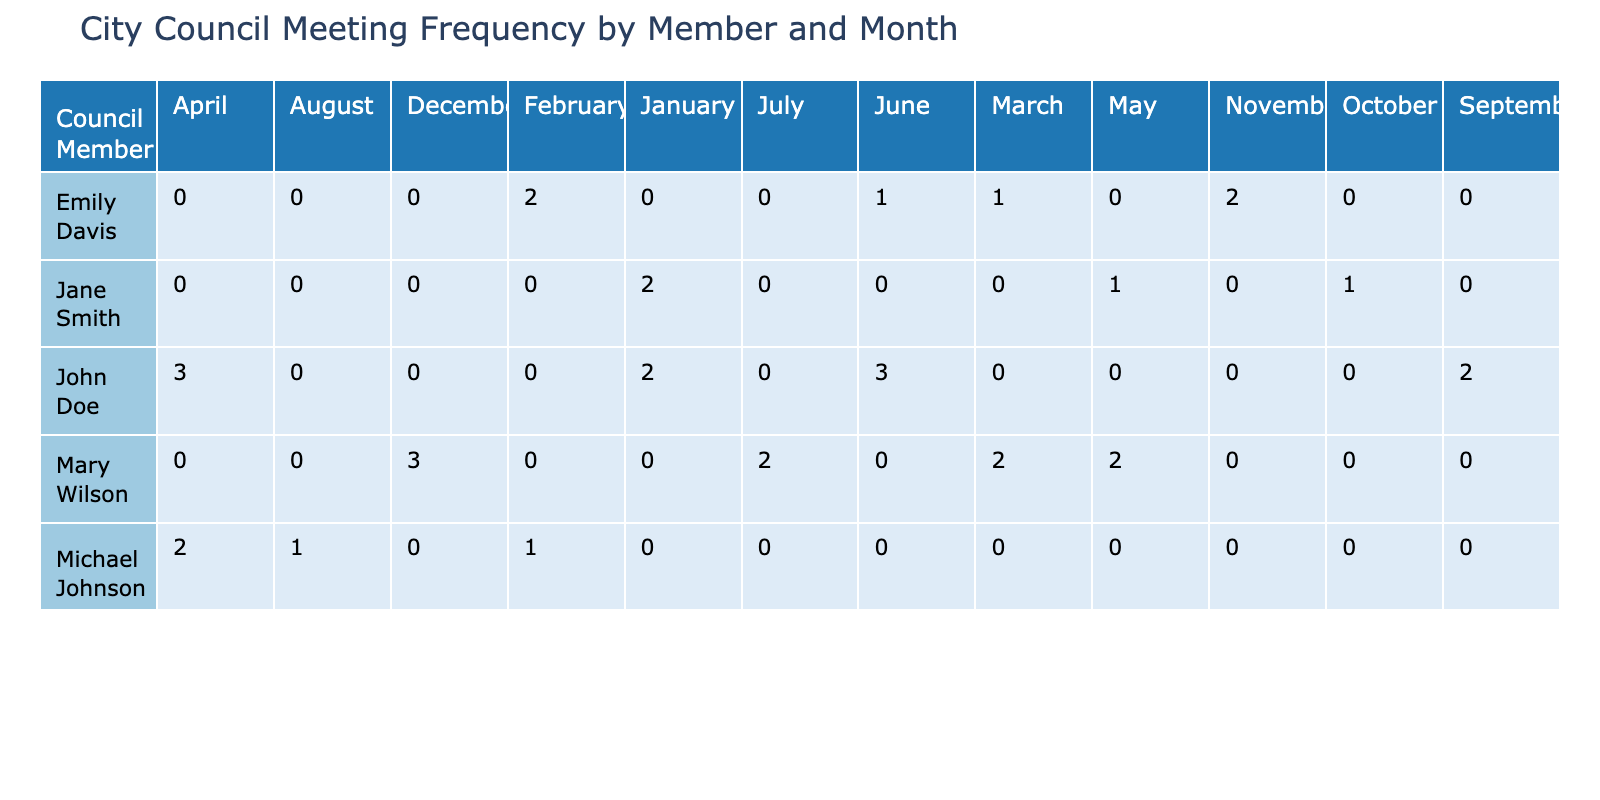What is the total number of meetings held by John Doe? To find the total number of meetings held by John Doe, I will look at the row for John Doe in the table and sum the values in the "Meeting_Count" column across all months. The values are 2 (January), 3 (April), 3 (June), and 2 (September), totaling 2 + 3 + 3 + 2 = 10.
Answer: 10 Which council member had the highest participation rate overall? I need to analyze the participation rates for each council member over the months. The maximum participation rates are: John Doe 100% (January, April, June, September), Jane Smith 100% (January, May), Emily Davis 100% (February), and Mary Wilson 100% (December). All these members had instances of 100%, thus it’s a tie among multiple members for the highest rate.
Answer: Tie among John Doe, Jane Smith, Emily Davis, and Mary Wilson How many meetings did Emily Davis attend in total? I will accumulate the "Meeting_Count" for Emily Davis. The values are 2 (February), 1 (March), 1 (June), and 2 (November), resulting in a total of 2 + 1 + 1 + 2 = 6 meetings attended.
Answer: 6 Is it true that Michael Johnson had a participation rate below 75% in any month? I look at Michael Johnson’s participation rates for each month: 100% (January), 50% (February), and 50% (August). Since he has two instances at 50%, which is below 75%, the answer is true.
Answer: Yes What is the average number of meetings attended by council members in March? In March, we have the following Meeting_Counts: Emily Davis 1 and Mary Wilson 2. To find the average, I sum these values (1 + 2 = 3) and then divide by the number of council members (2), giving an average of 3/2 = 1.5 meetings.
Answer: 1.5 Which month had the highest total number of meetings held? I will sum the meeting counts for each month: January (4), February (3), March (3), April (5), May (3), June (4), July (2), August (1), September (2), October (1), November (2), December (3). The highest total is in April with 5 meetings.
Answer: April Did any council member participate in more meetings than they attended? I verify this by comparing the "Meeting_Count" and "Participation_Rate" for each member. Participation rates indicate attendance in all listed meetings, so if a member has attended 100% for their meetings, it means they did not exceed attendance. Checking all members shows no instances of this violation.
Answer: No How many total meetings were held from January to March? I will sum the "Meeting_Count" for each of those months: January (4), February (3), and March (3). Thus, the total is 4 + 3 + 3 = 10 meetings over the three months.
Answer: 10 